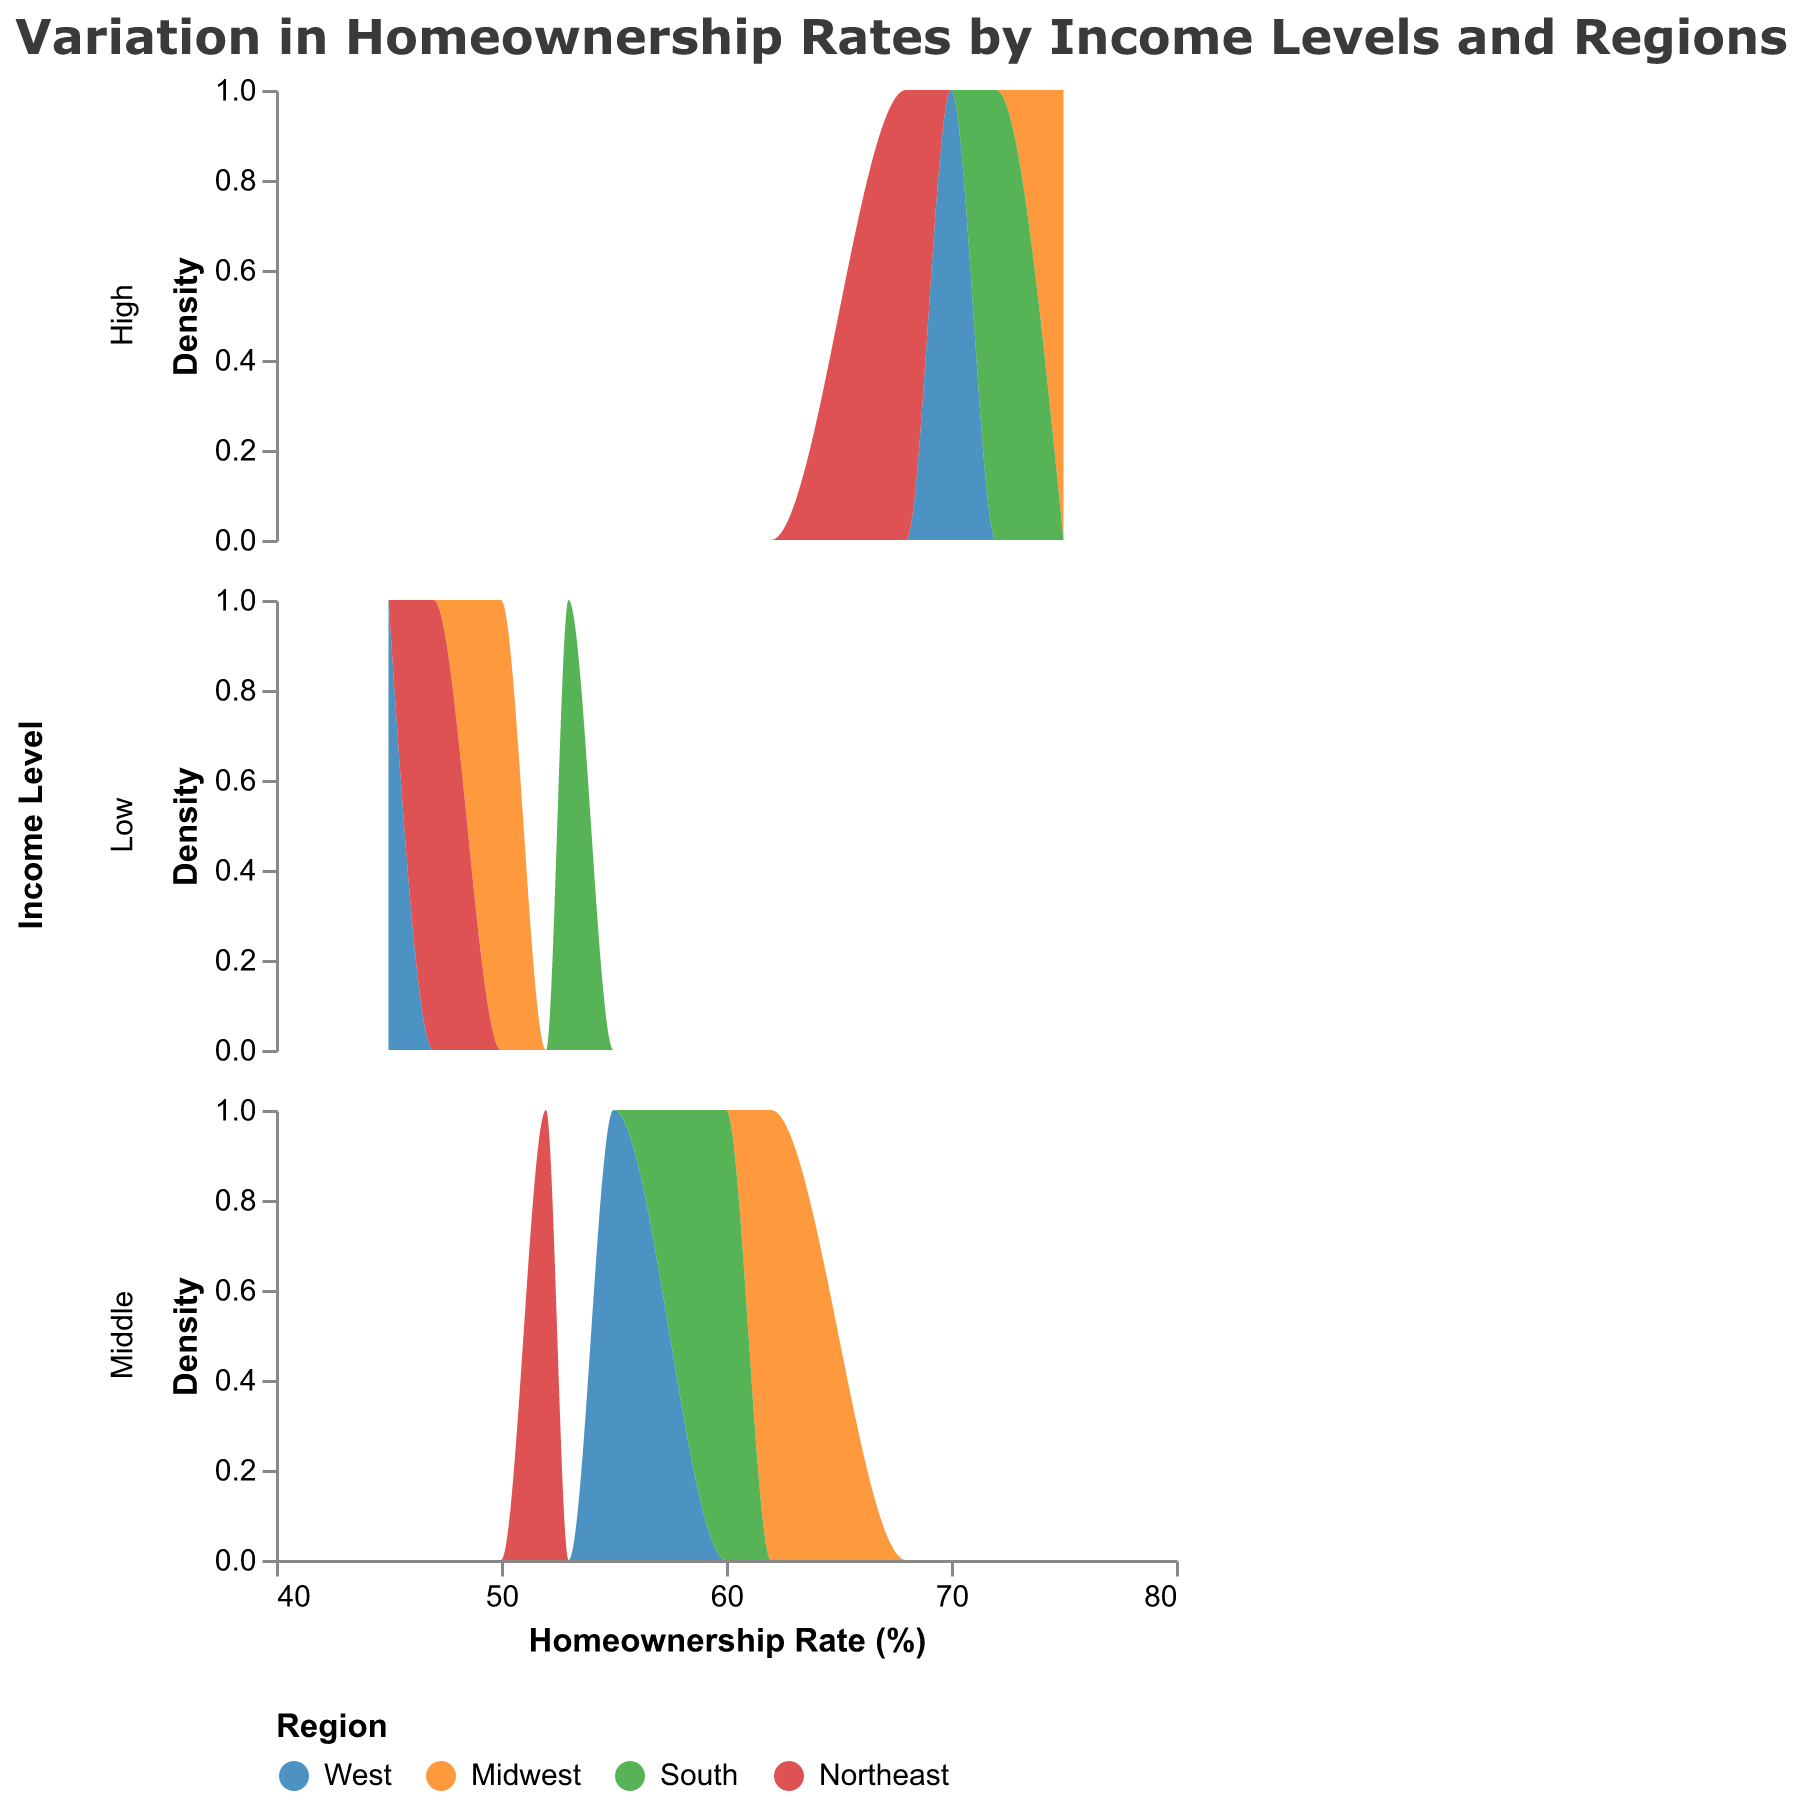What is the title of the figure? The title is displayed at the top of the figure and labeled as "Variation in Homeownership Rates by Income Levels and Regions".
Answer: Variation in Homeownership Rates by Income Levels and Regions Which region has the highest homeownership rate for the low-income level? The highest homeownership rates for the low-income level are shown by comparing the peaks in the density plot for each region. The South region peaks at 53%.
Answer: South How many homeownership rates are displayed for the high-income level? The high-income level subplot shows four data points, one for each region (West, Midwest, South, Northeast).
Answer: 4 Which income level shows the greatest variation in homeownership rates across different regions? The variation can be observed by comparing the spread of homeownership rates in each subplot. The middle-income level shows homeownership rates ranging from 52% to 62%, indicating the greatest variation.
Answer: Middle What is the average homeownership rate for the Northeast region across all income levels? To find the average, add the homeownership rates for the Northeast region at all income levels (47 + 52 + 68) and divide by the number of data points (3). (47 + 52 + 68) / 3 = 167 / 3 = 55.67
Answer: 55.67 Which region consistently has higher homeownership rates, regardless of income level? By comparing the density peaks across all income levels, the Midwest generally has higher homeownership rates (50, 62, 75) across all income levels.
Answer: Midwest What is the difference in homeownership rates between the highest and lowest regions for middle-income levels? Subtract the smallest homeownership rate among the regions in the middle-income group (52, Northeast) from the largest (62, Midwest). 62 - 52 = 10
Answer: 10 Which regions show overlapping homeownership rates for the high-income level? By examining the high-income subplot, the West (70) and Northeast (68) regions show overlapping homeownership rates.
Answer: West and Northeast How is the density of homeownership rates represented in the plot? The density of homeownership rates is represented by the y-axis, which aggregates the count of homeownership rates. Higher peaks mean higher density or more common values.
Answer: Aggregated count on y-axis What colors represent the South and Midwest regions, respectively? The legend keys show the color representation for each region; South is green and Midwest is orange.
Answer: South: Green, Midwest: Orange 